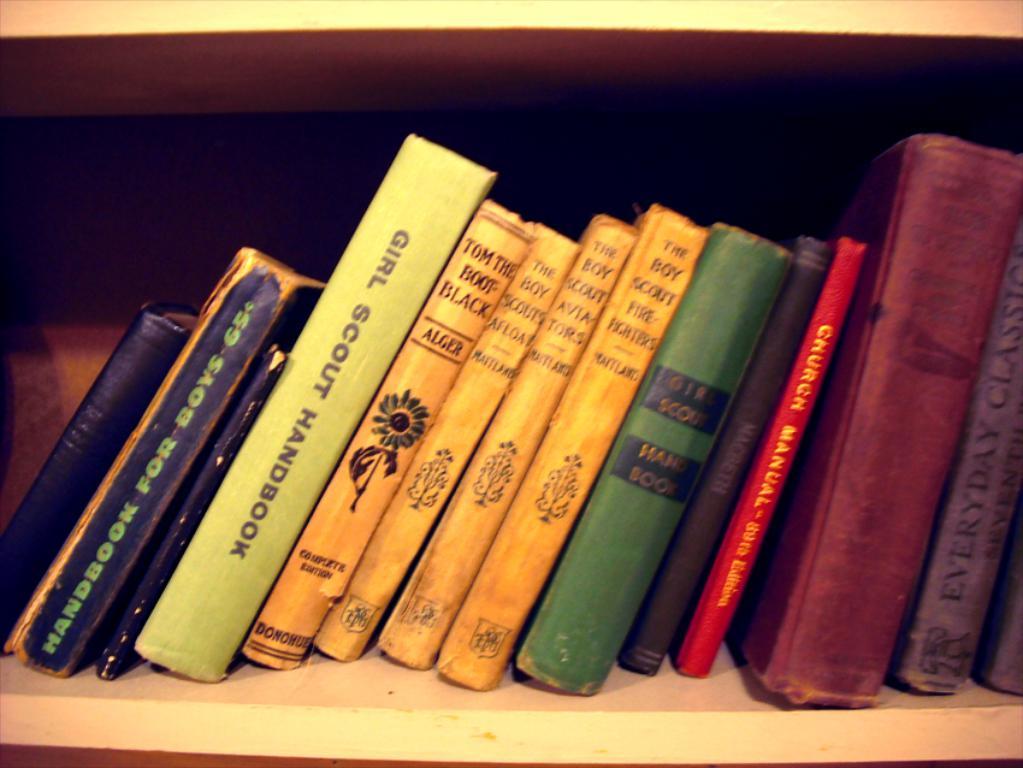What kinf od manual is the bright red book?
Give a very brief answer. Church. 